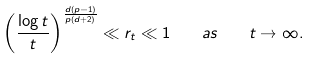Convert formula to latex. <formula><loc_0><loc_0><loc_500><loc_500>\left ( \frac { \log t } t \right ) ^ { \frac { d ( p - 1 ) } { p ( d + 2 ) } } \ll r _ { t } \ll 1 \quad a s \quad t \to \infty .</formula> 